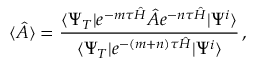Convert formula to latex. <formula><loc_0><loc_0><loc_500><loc_500>\langle \hat { A } \rangle = \frac { \langle \Psi _ { T } | e ^ { - m \tau \hat { H } } \hat { A } e ^ { - n \tau \hat { H } } | \Psi ^ { i } \rangle } { \langle \Psi _ { T } | e ^ { - ( m + n ) \tau \hat { H } } | \Psi ^ { i } \rangle } \, ,</formula> 